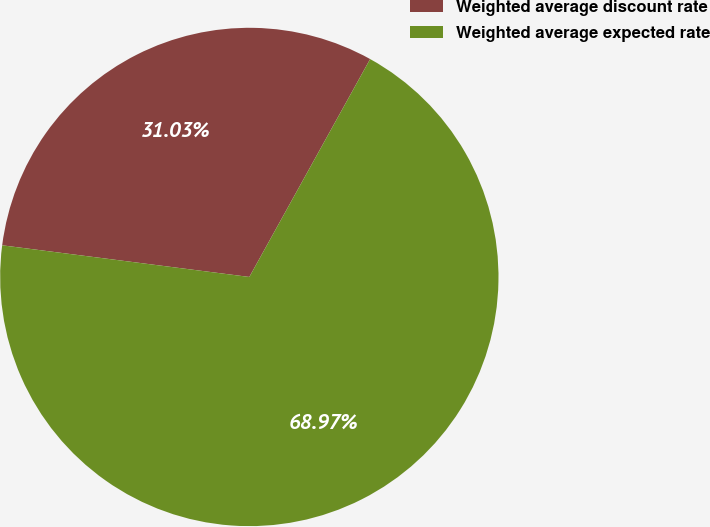Convert chart to OTSL. <chart><loc_0><loc_0><loc_500><loc_500><pie_chart><fcel>Weighted average discount rate<fcel>Weighted average expected rate<nl><fcel>31.03%<fcel>68.97%<nl></chart> 